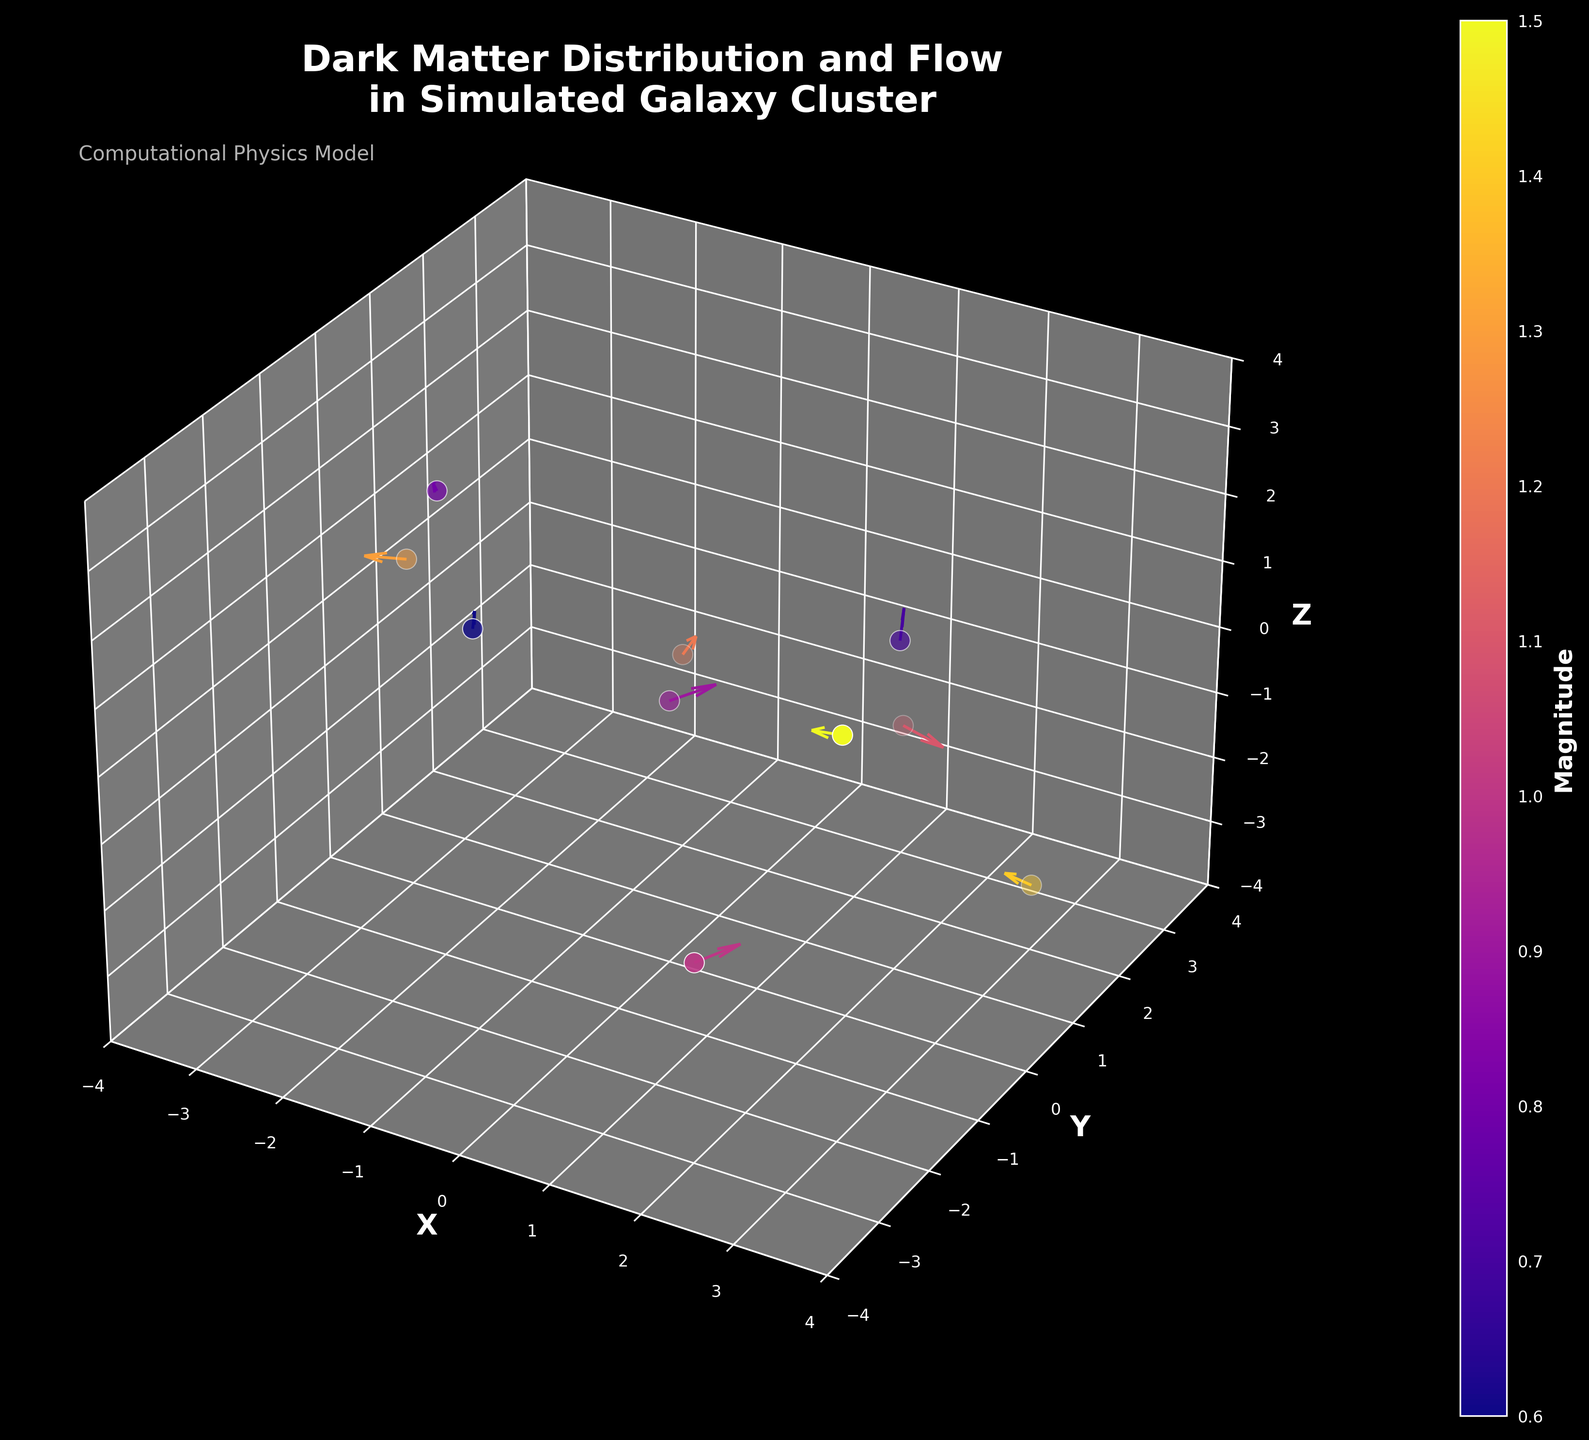What's the title of the figure? The title is displayed at the top of the figure and reads "Dark Matter Distribution and Flow in Simulated Galaxy Cluster", providing an overview of what the quiver plot represents.
Answer: Dark Matter Distribution and Flow in Simulated Galaxy Cluster What is the color associated with the highest magnitude region? By observing the color bar on the right side of the figure, the highest magnitude corresponds to the color at the top end of the scale, which is a bright yellow.
Answer: Bright yellow How many data points are plotted in the figure? By counting the number of quiver arrows and scatter points in the plot, we see there are 10 data points.
Answer: 10 Which axis shows the widest spread of data points? Observing the scatter points along the X, Y, and Z axes, we see the range for the X-axis is from -3 to 3, for the Y-axis from -3 to 3, and for the Z-axis from -3 to 3. Each axis covers the same range.
Answer: X, Y, and Z are equally spread Which data point shows the largest vector magnitude? By comparing the vector magnitudes (displayed as lengths of arrows) and cross-referencing with the color bar, the point at (3, -2, 2) has the largest vector magnitude, colored in bright yellow.
Answer: (3, -2, 2) What is the trend of the vectors along the positive X direction? In the quiver plot, vectors in the positive X direction (rightward from the origin) mostly have a positive X component but show a range of directions in Y and Z. For example, some of them point slightly upward or downward.
Answer: Positive X component with mixed Y and Z trends Which two axes have the largest distribution overlap of data points? Looking at the plot distribution along each axis, the Y and Z axes display the largest overlap of data points with several points sharing the same values along these axes periodically.
Answer: Y and Z How does the flow of dark matter change as we move from negative Z to positive Z? Observing the direction and density of the vectors from negative Z (backward) to positive Z (forward), vectors generally tend to show more variation and less uniformity in flow direction as magnitude changes.
Answer: More variation and complexity in flow direction What is the average magnitude of the vectors? To find the average magnitude, we sum the magnitudes of all vectors and divide by the number of vectors: (0.9 + 0.7 + 1.2 + 1.5 + 0.8 + 1.1 + 1.3 + 1.0 + 0.6 + 1.4) / 10 = 10.5 / 10 = 1.05.
Answer: 1.05 Compare the colors of vectors at (2,-3,-1) and (-1,2,-1). Which one has a higher magnitude? The color bar indicates magnitude, and by comparing the colors on the bar, the vector at (2,-3,-1) is more yellowish than the vector at (-1,2,-1), indicating higher magnitude.
Answer: (2,-3,-1) 